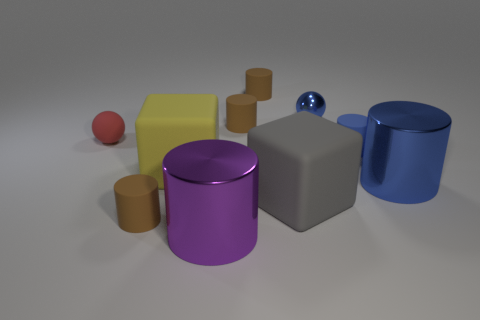How many brown cylinders must be subtracted to get 1 brown cylinders? 2 Subtract all rubber cylinders. How many cylinders are left? 2 Subtract all blue cubes. How many brown cylinders are left? 3 Subtract all blue balls. How many balls are left? 1 Subtract 4 cylinders. How many cylinders are left? 2 Subtract all cubes. How many objects are left? 8 Subtract all tiny brown rubber cylinders. Subtract all big yellow objects. How many objects are left? 6 Add 7 tiny rubber balls. How many tiny rubber balls are left? 8 Add 3 large blue matte cubes. How many large blue matte cubes exist? 3 Subtract 2 blue cylinders. How many objects are left? 8 